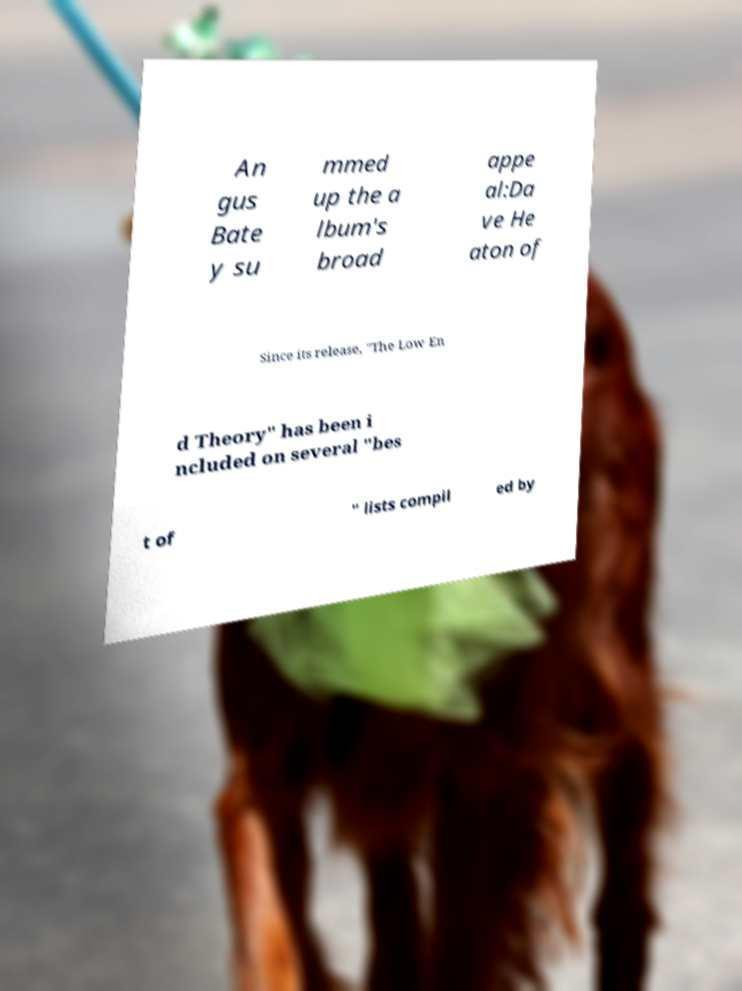Could you assist in decoding the text presented in this image and type it out clearly? An gus Bate y su mmed up the a lbum's broad appe al:Da ve He aton of Since its release, "The Low En d Theory" has been i ncluded on several "bes t of " lists compil ed by 